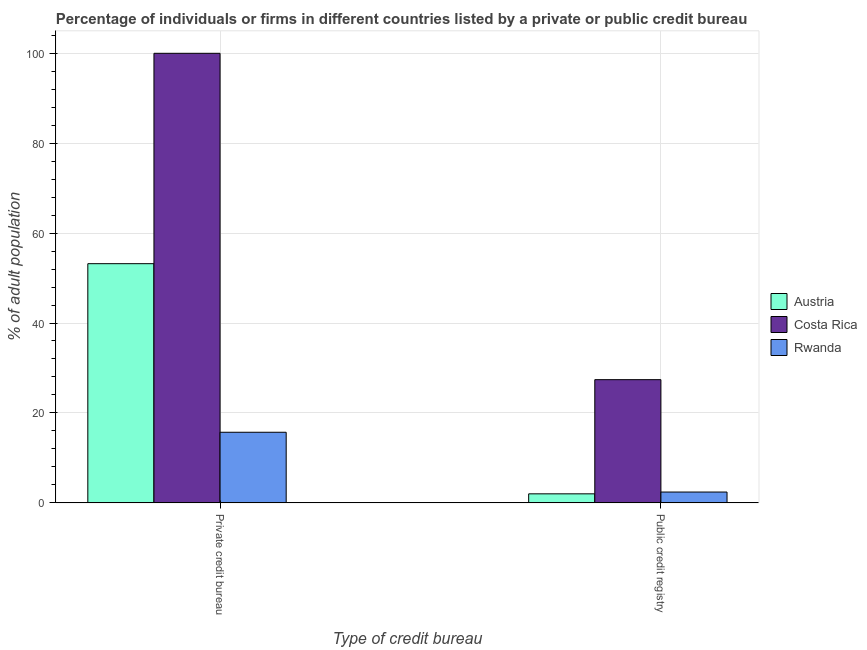How many groups of bars are there?
Your answer should be very brief. 2. How many bars are there on the 2nd tick from the right?
Provide a succinct answer. 3. What is the label of the 2nd group of bars from the left?
Offer a terse response. Public credit registry. What is the percentage of firms listed by public credit bureau in Costa Rica?
Keep it short and to the point. 27.4. Across all countries, what is the maximum percentage of firms listed by public credit bureau?
Keep it short and to the point. 27.4. Across all countries, what is the minimum percentage of firms listed by private credit bureau?
Your answer should be very brief. 15.7. In which country was the percentage of firms listed by private credit bureau maximum?
Offer a very short reply. Costa Rica. In which country was the percentage of firms listed by private credit bureau minimum?
Give a very brief answer. Rwanda. What is the total percentage of firms listed by private credit bureau in the graph?
Your answer should be compact. 168.9. What is the difference between the percentage of firms listed by private credit bureau in Costa Rica and that in Austria?
Provide a succinct answer. 46.8. What is the average percentage of firms listed by public credit bureau per country?
Give a very brief answer. 10.6. What is the difference between the percentage of firms listed by public credit bureau and percentage of firms listed by private credit bureau in Austria?
Make the answer very short. -51.2. In how many countries, is the percentage of firms listed by private credit bureau greater than 16 %?
Your response must be concise. 2. What is the ratio of the percentage of firms listed by public credit bureau in Rwanda to that in Austria?
Ensure brevity in your answer.  1.2. Is the percentage of firms listed by private credit bureau in Austria less than that in Rwanda?
Your answer should be compact. No. In how many countries, is the percentage of firms listed by private credit bureau greater than the average percentage of firms listed by private credit bureau taken over all countries?
Offer a terse response. 1. How many countries are there in the graph?
Provide a succinct answer. 3. Are the values on the major ticks of Y-axis written in scientific E-notation?
Offer a terse response. No. Where does the legend appear in the graph?
Offer a very short reply. Center right. How are the legend labels stacked?
Offer a terse response. Vertical. What is the title of the graph?
Your answer should be compact. Percentage of individuals or firms in different countries listed by a private or public credit bureau. Does "Central Europe" appear as one of the legend labels in the graph?
Ensure brevity in your answer.  No. What is the label or title of the X-axis?
Ensure brevity in your answer.  Type of credit bureau. What is the label or title of the Y-axis?
Provide a short and direct response. % of adult population. What is the % of adult population of Austria in Private credit bureau?
Keep it short and to the point. 53.2. What is the % of adult population in Costa Rica in Private credit bureau?
Provide a short and direct response. 100. What is the % of adult population in Rwanda in Private credit bureau?
Offer a very short reply. 15.7. What is the % of adult population of Austria in Public credit registry?
Your answer should be compact. 2. What is the % of adult population in Costa Rica in Public credit registry?
Offer a terse response. 27.4. What is the % of adult population in Rwanda in Public credit registry?
Provide a succinct answer. 2.4. Across all Type of credit bureau, what is the maximum % of adult population in Austria?
Make the answer very short. 53.2. Across all Type of credit bureau, what is the maximum % of adult population of Costa Rica?
Your response must be concise. 100. Across all Type of credit bureau, what is the maximum % of adult population of Rwanda?
Give a very brief answer. 15.7. Across all Type of credit bureau, what is the minimum % of adult population of Costa Rica?
Your response must be concise. 27.4. What is the total % of adult population in Austria in the graph?
Offer a very short reply. 55.2. What is the total % of adult population in Costa Rica in the graph?
Make the answer very short. 127.4. What is the difference between the % of adult population in Austria in Private credit bureau and that in Public credit registry?
Ensure brevity in your answer.  51.2. What is the difference between the % of adult population of Costa Rica in Private credit bureau and that in Public credit registry?
Your answer should be compact. 72.6. What is the difference between the % of adult population of Austria in Private credit bureau and the % of adult population of Costa Rica in Public credit registry?
Your response must be concise. 25.8. What is the difference between the % of adult population of Austria in Private credit bureau and the % of adult population of Rwanda in Public credit registry?
Provide a short and direct response. 50.8. What is the difference between the % of adult population in Costa Rica in Private credit bureau and the % of adult population in Rwanda in Public credit registry?
Your answer should be compact. 97.6. What is the average % of adult population in Austria per Type of credit bureau?
Your answer should be compact. 27.6. What is the average % of adult population of Costa Rica per Type of credit bureau?
Make the answer very short. 63.7. What is the average % of adult population of Rwanda per Type of credit bureau?
Keep it short and to the point. 9.05. What is the difference between the % of adult population in Austria and % of adult population in Costa Rica in Private credit bureau?
Keep it short and to the point. -46.8. What is the difference between the % of adult population in Austria and % of adult population in Rwanda in Private credit bureau?
Your answer should be very brief. 37.5. What is the difference between the % of adult population in Costa Rica and % of adult population in Rwanda in Private credit bureau?
Offer a terse response. 84.3. What is the difference between the % of adult population of Austria and % of adult population of Costa Rica in Public credit registry?
Give a very brief answer. -25.4. What is the difference between the % of adult population in Costa Rica and % of adult population in Rwanda in Public credit registry?
Keep it short and to the point. 25. What is the ratio of the % of adult population in Austria in Private credit bureau to that in Public credit registry?
Your answer should be compact. 26.6. What is the ratio of the % of adult population of Costa Rica in Private credit bureau to that in Public credit registry?
Your response must be concise. 3.65. What is the ratio of the % of adult population in Rwanda in Private credit bureau to that in Public credit registry?
Make the answer very short. 6.54. What is the difference between the highest and the second highest % of adult population in Austria?
Ensure brevity in your answer.  51.2. What is the difference between the highest and the second highest % of adult population of Costa Rica?
Offer a terse response. 72.6. What is the difference between the highest and the second highest % of adult population in Rwanda?
Your response must be concise. 13.3. What is the difference between the highest and the lowest % of adult population of Austria?
Provide a short and direct response. 51.2. What is the difference between the highest and the lowest % of adult population in Costa Rica?
Offer a terse response. 72.6. 